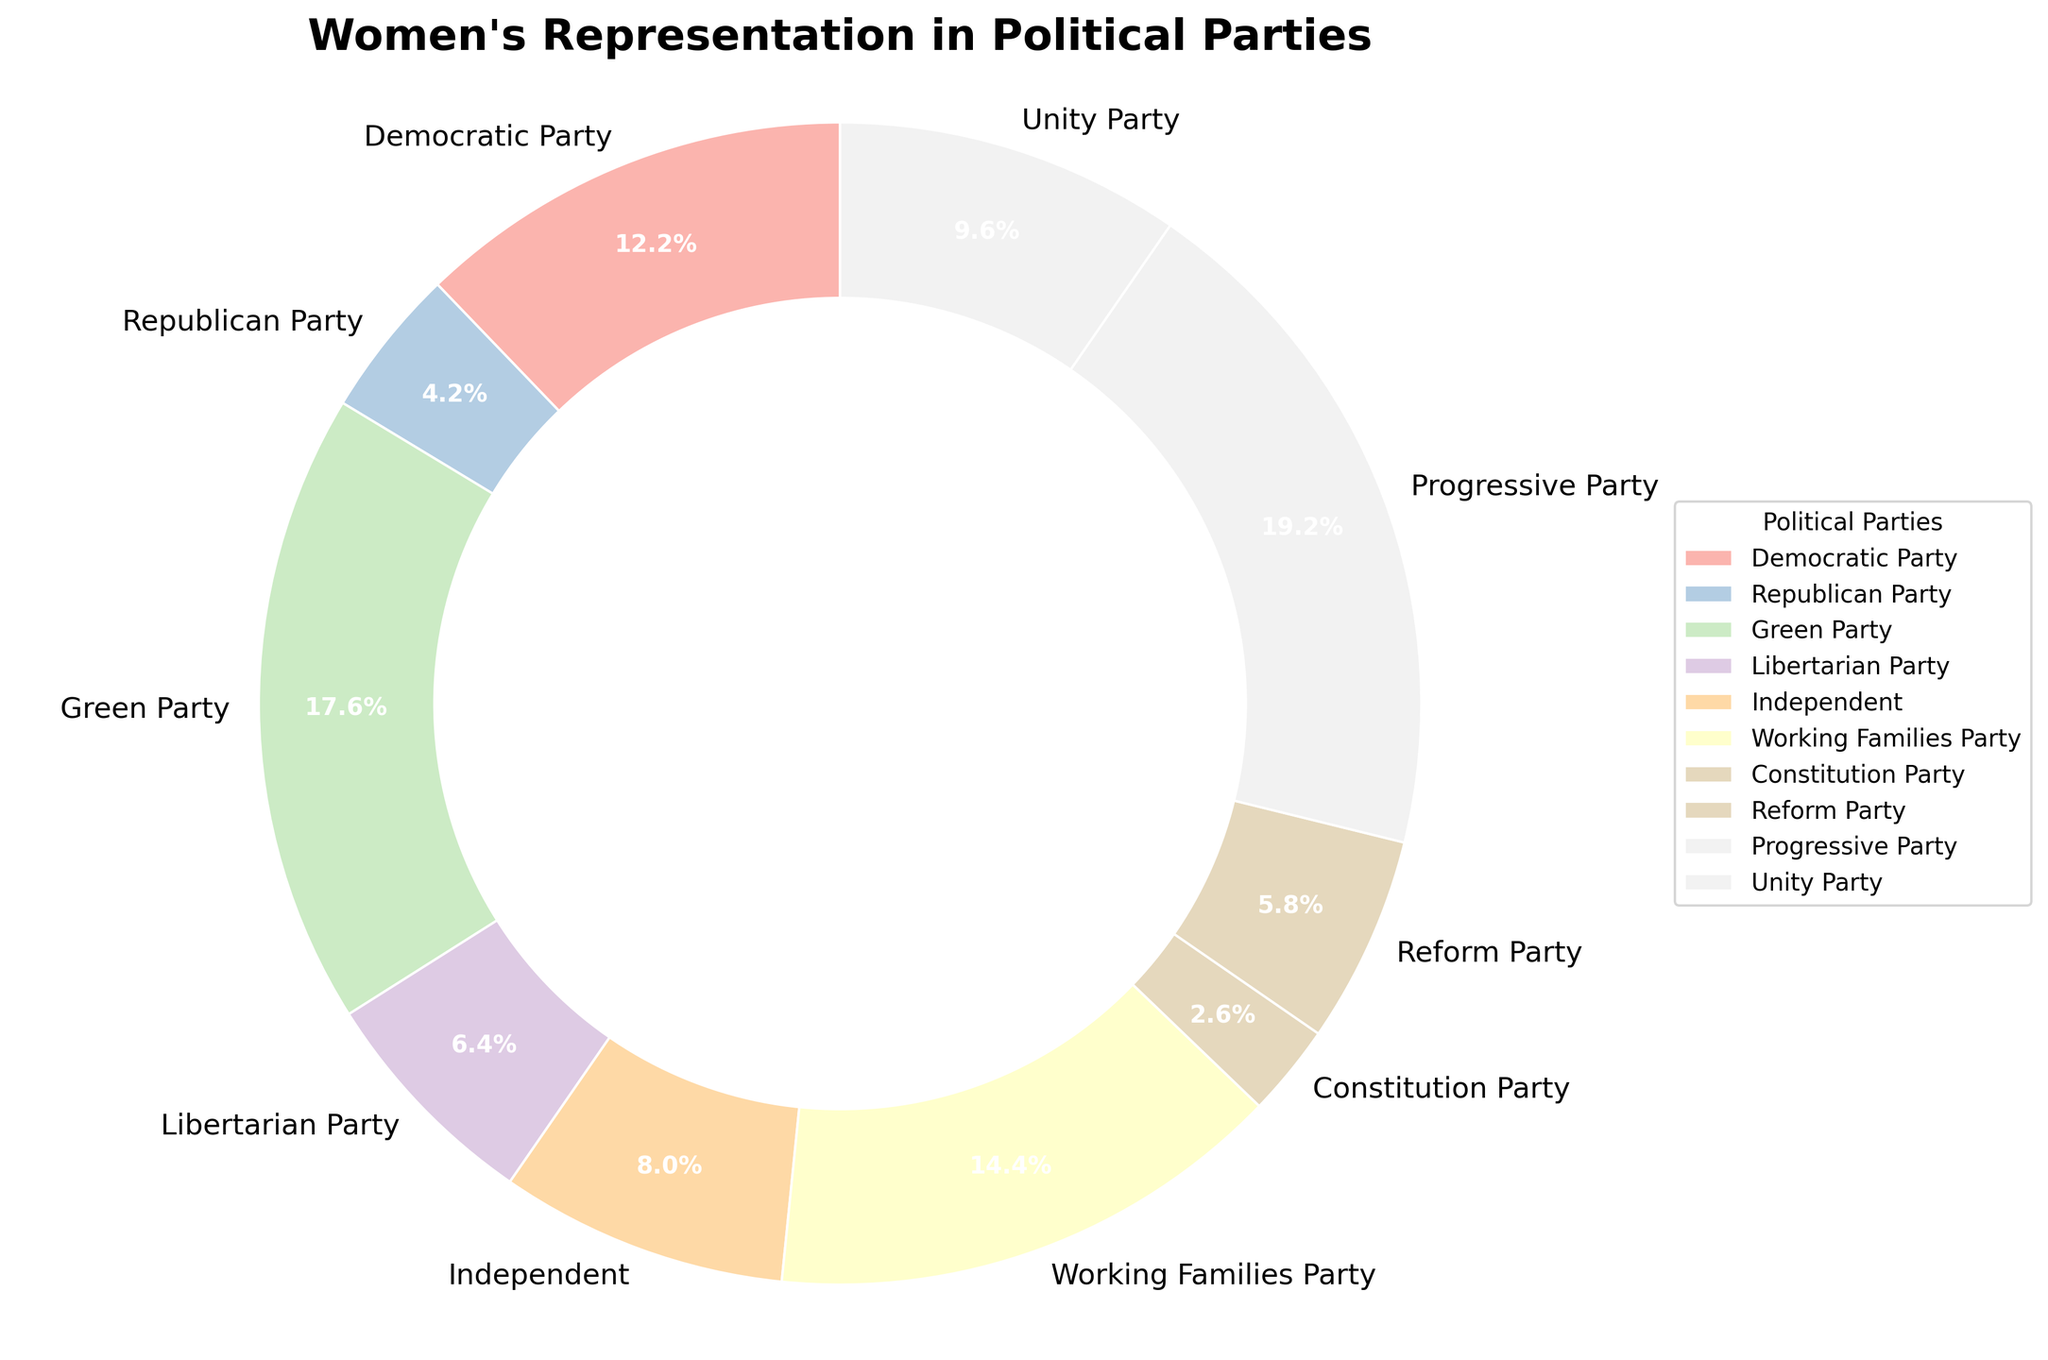Which political party has the highest representation of women? By examining the pie chart, the largest wedge is for the Progressive Party, indicating that they have the highest percentage representation.
Answer: Progressive Party Which political party has the lowest representation of women? The smallest wedge in the pie chart represents the Constitution Party, indicating they have the lowest percentage representation of women.
Answer: Constitution Party What is the difference in women's representation between the Democratic Party and the Republican Party? According to the pie chart, the Democratic Party has 38% women representation and the Republican Party has 13%. Calculating the difference: 38% - 13% = 25%.
Answer: 25% Which political party has more women representation, the Green Party or the Independent party? In the pie chart, the Green Party has a larger wedge at 55% compared to the Independent's 25%, indicating the Green Party has more women representation.
Answer: Green Party How much higher is the women's representation in the Working Families Party compared to the Libertarian Party? The Working Families Party has 45% while the Libertarian Party has 20% women representation. Subtracting these values gives 45% - 20% = 25%.
Answer: 25% What is the sum of women's representation for the Green Party, Reform Party, and Unity Party? According to the pie chart, the Green Party has 55%, the Reform Party has 18%, and the Unity Party has 30%. Adding these percentages: 55% + 18% + 30% = 103%.
Answer: 103% How does the representation of women in the Working Families Party compare to the Democratic Party? The pie chart shows that the Working Families Party has a 45% representation, while the Democratic Party has 38%. 45% is higher than 38%.
Answer: Higher What is the average women's representation across the Democratic Party, Republican Party, and Progressive Party? From the pie chart, their representations are 38%, 13%, and 60%. The average is calculated as (38 + 13 + 60) / 3 = 111 / 3 = 37%.
Answer: 37% Is the representation of women in the Unity Party higher or lower than that in the Independent party? The Unity Party's wedge is marked at 30%, while the Independent party's wedge is marked at 25%. Thus, the Unity Party's representation of women is higher.
Answer: Higher Which two parties have the closest women representation and what are their percentages? By looking at the pie chart, the Democratic Party (38%) and the Unity Party (30%) have the closest percentages. The difference is 38% - 30% = 8%.
Answer: Democratic Party and Unity Party, 38% and 30% 